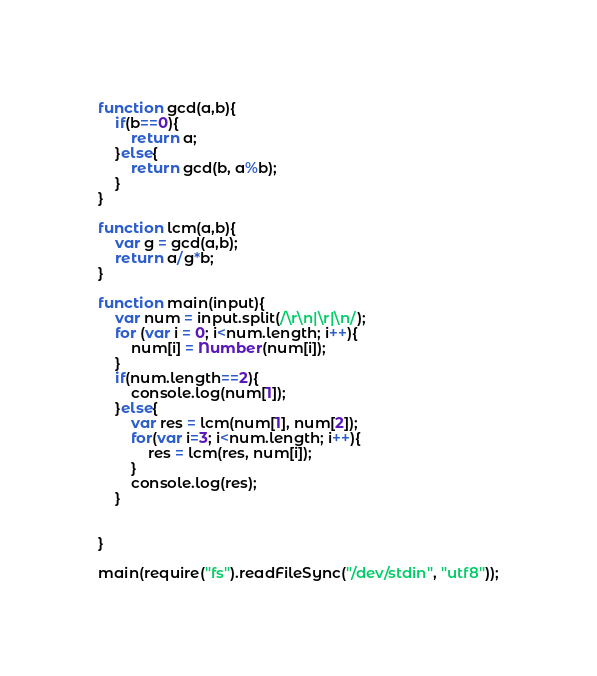<code> <loc_0><loc_0><loc_500><loc_500><_JavaScript_>function gcd(a,b){
    if(b==0){
        return a;
    }else{
        return gcd(b, a%b);
    }
}

function lcm(a,b){
    var g = gcd(a,b);
    return a/g*b;
}

function main(input){
    var num = input.split(/\r\n|\r|\n/);
    for (var i = 0; i<num.length; i++){
        num[i] = Number(num[i]);
    }
    if(num.length==2){
        console.log(num[1]);
    }else{
        var res = lcm(num[1], num[2]);
        for(var i=3; i<num.length; i++){
            res = lcm(res, num[i]);
        }
        console.log(res);
    }


}

main(require("fs").readFileSync("/dev/stdin", "utf8"));</code> 